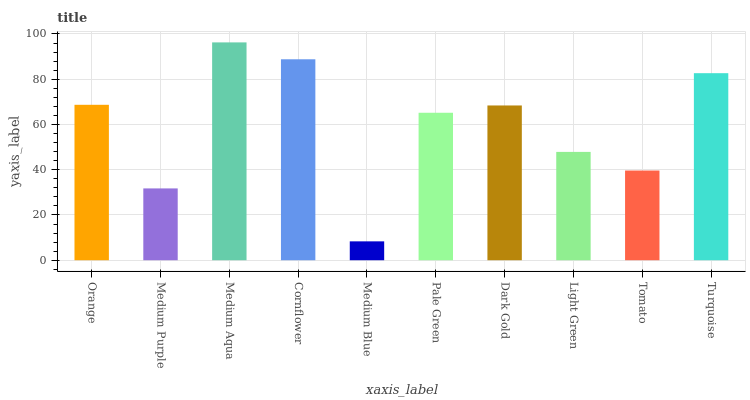Is Medium Blue the minimum?
Answer yes or no. Yes. Is Medium Aqua the maximum?
Answer yes or no. Yes. Is Medium Purple the minimum?
Answer yes or no. No. Is Medium Purple the maximum?
Answer yes or no. No. Is Orange greater than Medium Purple?
Answer yes or no. Yes. Is Medium Purple less than Orange?
Answer yes or no. Yes. Is Medium Purple greater than Orange?
Answer yes or no. No. Is Orange less than Medium Purple?
Answer yes or no. No. Is Dark Gold the high median?
Answer yes or no. Yes. Is Pale Green the low median?
Answer yes or no. Yes. Is Pale Green the high median?
Answer yes or no. No. Is Turquoise the low median?
Answer yes or no. No. 